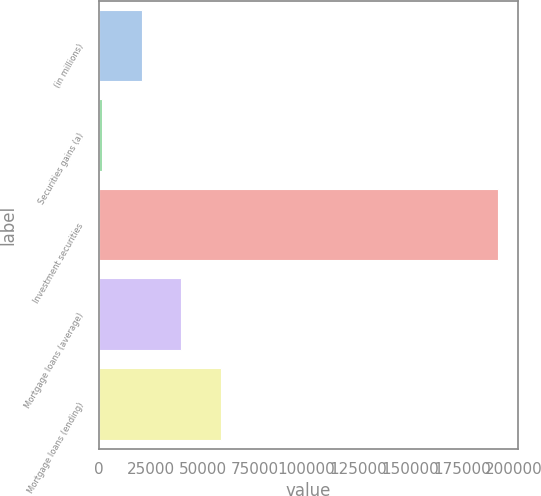<chart> <loc_0><loc_0><loc_500><loc_500><bar_chart><fcel>(in millions)<fcel>Securities gains (a)<fcel>Investment securities<fcel>Mortgage loans (average)<fcel>Mortgage loans (ending)<nl><fcel>20743.2<fcel>1652<fcel>192564<fcel>39834.4<fcel>58925.6<nl></chart> 